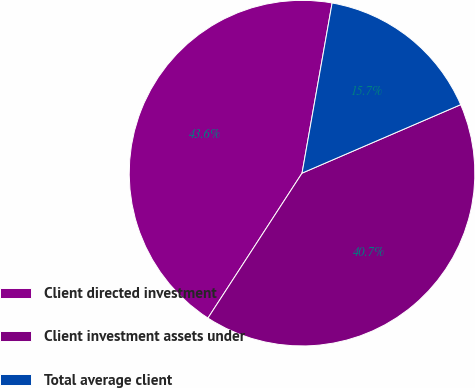<chart> <loc_0><loc_0><loc_500><loc_500><pie_chart><fcel>Client directed investment<fcel>Client investment assets under<fcel>Total average client<nl><fcel>43.62%<fcel>40.65%<fcel>15.73%<nl></chart> 